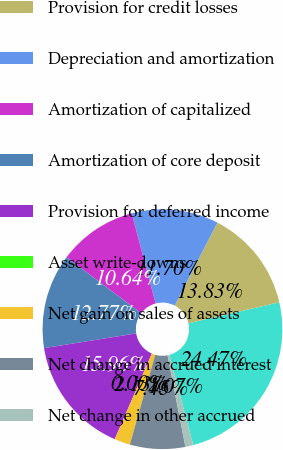<chart> <loc_0><loc_0><loc_500><loc_500><pie_chart><fcel>Net income<fcel>Provision for credit losses<fcel>Depreciation and amortization<fcel>Amortization of capitalized<fcel>Amortization of core deposit<fcel>Provision for deferred income<fcel>Asset write-downs<fcel>Net gain on sales of assets<fcel>Net change in accrued interest<fcel>Net change in other accrued<nl><fcel>24.47%<fcel>13.83%<fcel>11.7%<fcel>10.64%<fcel>12.77%<fcel>15.96%<fcel>0.0%<fcel>2.13%<fcel>7.45%<fcel>1.07%<nl></chart> 